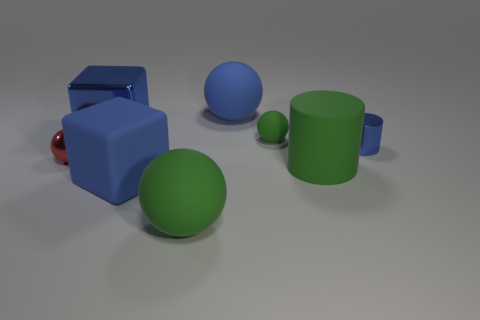How many big things are either matte things or green matte objects?
Give a very brief answer. 4. What material is the tiny green object that is the same shape as the tiny red shiny object?
Your answer should be compact. Rubber. Are there any other things that have the same material as the tiny green sphere?
Your answer should be very brief. Yes. The small rubber sphere is what color?
Your response must be concise. Green. Does the big metal object have the same color as the tiny shiny sphere?
Give a very brief answer. No. There is a green matte ball that is behind the tiny blue object; how many big blue matte things are behind it?
Offer a very short reply. 1. What is the size of the green matte thing that is in front of the small cylinder and right of the big blue sphere?
Your answer should be compact. Large. What material is the big green object that is right of the big green sphere?
Offer a very short reply. Rubber. Is there another tiny blue metal object that has the same shape as the tiny blue shiny thing?
Provide a short and direct response. No. What number of green objects are the same shape as the tiny red object?
Provide a succinct answer. 2. 